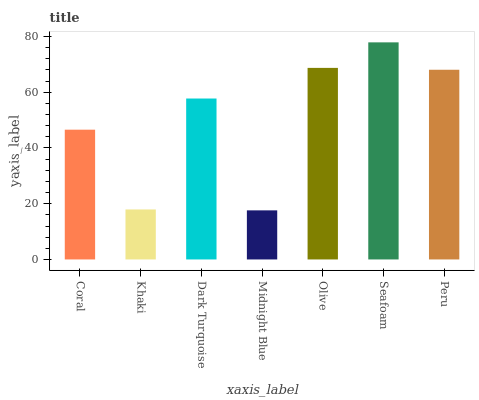Is Midnight Blue the minimum?
Answer yes or no. Yes. Is Seafoam the maximum?
Answer yes or no. Yes. Is Khaki the minimum?
Answer yes or no. No. Is Khaki the maximum?
Answer yes or no. No. Is Coral greater than Khaki?
Answer yes or no. Yes. Is Khaki less than Coral?
Answer yes or no. Yes. Is Khaki greater than Coral?
Answer yes or no. No. Is Coral less than Khaki?
Answer yes or no. No. Is Dark Turquoise the high median?
Answer yes or no. Yes. Is Dark Turquoise the low median?
Answer yes or no. Yes. Is Khaki the high median?
Answer yes or no. No. Is Seafoam the low median?
Answer yes or no. No. 